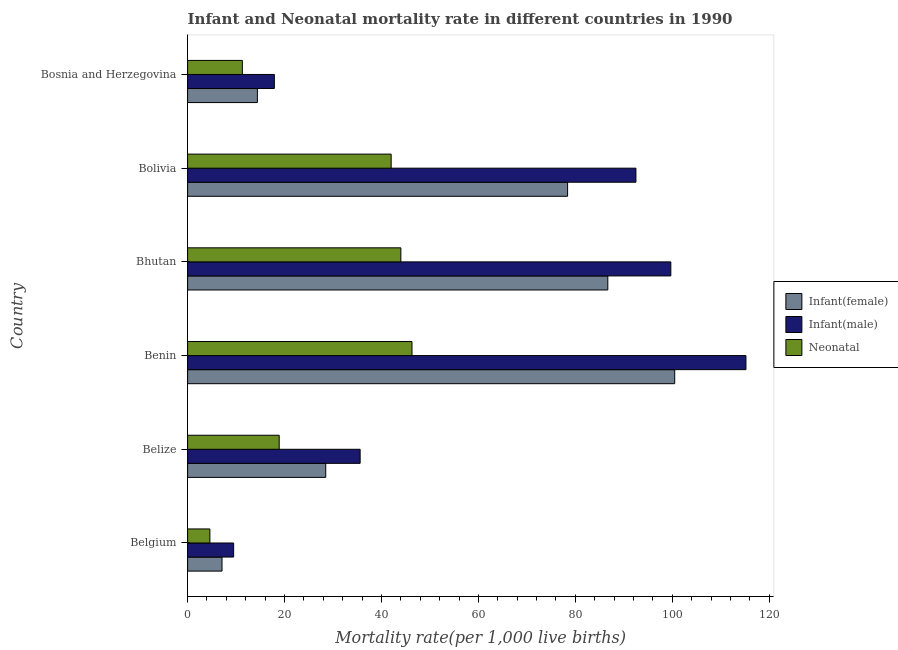How many different coloured bars are there?
Offer a terse response. 3. Are the number of bars per tick equal to the number of legend labels?
Offer a very short reply. Yes. How many bars are there on the 2nd tick from the bottom?
Keep it short and to the point. 3. What is the label of the 4th group of bars from the top?
Ensure brevity in your answer.  Benin. In how many cases, is the number of bars for a given country not equal to the number of legend labels?
Your answer should be very brief. 0. Across all countries, what is the maximum infant mortality rate(female)?
Offer a very short reply. 100.5. Across all countries, what is the minimum infant mortality rate(male)?
Your answer should be compact. 9.5. In which country was the neonatal mortality rate maximum?
Your answer should be very brief. Benin. In which country was the infant mortality rate(male) minimum?
Give a very brief answer. Belgium. What is the total infant mortality rate(female) in the graph?
Provide a succinct answer. 315.6. What is the difference between the infant mortality rate(female) in Belgium and that in Belize?
Your answer should be very brief. -21.4. What is the difference between the infant mortality rate(female) in Benin and the neonatal mortality rate in Bosnia and Herzegovina?
Make the answer very short. 89.2. What is the average infant mortality rate(male) per country?
Keep it short and to the point. 61.73. What is the difference between the neonatal mortality rate and infant mortality rate(female) in Benin?
Make the answer very short. -54.2. In how many countries, is the infant mortality rate(female) greater than 92 ?
Your answer should be compact. 1. What is the ratio of the neonatal mortality rate in Belgium to that in Belize?
Provide a short and direct response. 0.24. Is the infant mortality rate(female) in Belgium less than that in Bhutan?
Your answer should be compact. Yes. Is the difference between the infant mortality rate(male) in Belize and Bosnia and Herzegovina greater than the difference between the infant mortality rate(female) in Belize and Bosnia and Herzegovina?
Your response must be concise. Yes. What is the difference between the highest and the lowest infant mortality rate(female)?
Make the answer very short. 93.4. Is the sum of the infant mortality rate(female) in Bhutan and Bolivia greater than the maximum neonatal mortality rate across all countries?
Keep it short and to the point. Yes. What does the 3rd bar from the top in Belgium represents?
Make the answer very short. Infant(female). What does the 2nd bar from the bottom in Bolivia represents?
Your answer should be compact. Infant(male). Are all the bars in the graph horizontal?
Your answer should be very brief. Yes. How many countries are there in the graph?
Offer a terse response. 6. Does the graph contain grids?
Provide a succinct answer. No. How many legend labels are there?
Give a very brief answer. 3. What is the title of the graph?
Your response must be concise. Infant and Neonatal mortality rate in different countries in 1990. Does "Ages 15-20" appear as one of the legend labels in the graph?
Provide a short and direct response. No. What is the label or title of the X-axis?
Provide a succinct answer. Mortality rate(per 1,0 live births). What is the Mortality rate(per 1,000 live births) in Infant(female) in Belgium?
Keep it short and to the point. 7.1. What is the Mortality rate(per 1,000 live births) of Infant(male) in Belgium?
Provide a short and direct response. 9.5. What is the Mortality rate(per 1,000 live births) in Infant(male) in Belize?
Make the answer very short. 35.6. What is the Mortality rate(per 1,000 live births) in Infant(female) in Benin?
Your answer should be very brief. 100.5. What is the Mortality rate(per 1,000 live births) of Infant(male) in Benin?
Keep it short and to the point. 115.2. What is the Mortality rate(per 1,000 live births) in Neonatal  in Benin?
Make the answer very short. 46.3. What is the Mortality rate(per 1,000 live births) in Infant(female) in Bhutan?
Provide a succinct answer. 86.7. What is the Mortality rate(per 1,000 live births) of Infant(male) in Bhutan?
Keep it short and to the point. 99.7. What is the Mortality rate(per 1,000 live births) of Infant(female) in Bolivia?
Make the answer very short. 78.4. What is the Mortality rate(per 1,000 live births) of Infant(male) in Bolivia?
Keep it short and to the point. 92.5. What is the Mortality rate(per 1,000 live births) of Neonatal  in Bolivia?
Your answer should be compact. 42. What is the Mortality rate(per 1,000 live births) in Infant(female) in Bosnia and Herzegovina?
Provide a succinct answer. 14.4. What is the Mortality rate(per 1,000 live births) in Infant(male) in Bosnia and Herzegovina?
Give a very brief answer. 17.9. What is the Mortality rate(per 1,000 live births) in Neonatal  in Bosnia and Herzegovina?
Provide a succinct answer. 11.3. Across all countries, what is the maximum Mortality rate(per 1,000 live births) in Infant(female)?
Your response must be concise. 100.5. Across all countries, what is the maximum Mortality rate(per 1,000 live births) of Infant(male)?
Keep it short and to the point. 115.2. Across all countries, what is the maximum Mortality rate(per 1,000 live births) in Neonatal ?
Keep it short and to the point. 46.3. What is the total Mortality rate(per 1,000 live births) in Infant(female) in the graph?
Your response must be concise. 315.6. What is the total Mortality rate(per 1,000 live births) in Infant(male) in the graph?
Give a very brief answer. 370.4. What is the total Mortality rate(per 1,000 live births) of Neonatal  in the graph?
Your response must be concise. 167.1. What is the difference between the Mortality rate(per 1,000 live births) of Infant(female) in Belgium and that in Belize?
Make the answer very short. -21.4. What is the difference between the Mortality rate(per 1,000 live births) in Infant(male) in Belgium and that in Belize?
Make the answer very short. -26.1. What is the difference between the Mortality rate(per 1,000 live births) of Neonatal  in Belgium and that in Belize?
Your answer should be compact. -14.3. What is the difference between the Mortality rate(per 1,000 live births) of Infant(female) in Belgium and that in Benin?
Provide a succinct answer. -93.4. What is the difference between the Mortality rate(per 1,000 live births) in Infant(male) in Belgium and that in Benin?
Your answer should be compact. -105.7. What is the difference between the Mortality rate(per 1,000 live births) in Neonatal  in Belgium and that in Benin?
Ensure brevity in your answer.  -41.7. What is the difference between the Mortality rate(per 1,000 live births) in Infant(female) in Belgium and that in Bhutan?
Your answer should be very brief. -79.6. What is the difference between the Mortality rate(per 1,000 live births) in Infant(male) in Belgium and that in Bhutan?
Offer a very short reply. -90.2. What is the difference between the Mortality rate(per 1,000 live births) of Neonatal  in Belgium and that in Bhutan?
Give a very brief answer. -39.4. What is the difference between the Mortality rate(per 1,000 live births) of Infant(female) in Belgium and that in Bolivia?
Offer a very short reply. -71.3. What is the difference between the Mortality rate(per 1,000 live births) in Infant(male) in Belgium and that in Bolivia?
Your answer should be compact. -83. What is the difference between the Mortality rate(per 1,000 live births) in Neonatal  in Belgium and that in Bolivia?
Provide a succinct answer. -37.4. What is the difference between the Mortality rate(per 1,000 live births) in Infant(female) in Belgium and that in Bosnia and Herzegovina?
Provide a succinct answer. -7.3. What is the difference between the Mortality rate(per 1,000 live births) in Neonatal  in Belgium and that in Bosnia and Herzegovina?
Give a very brief answer. -6.7. What is the difference between the Mortality rate(per 1,000 live births) of Infant(female) in Belize and that in Benin?
Your answer should be compact. -72. What is the difference between the Mortality rate(per 1,000 live births) of Infant(male) in Belize and that in Benin?
Make the answer very short. -79.6. What is the difference between the Mortality rate(per 1,000 live births) in Neonatal  in Belize and that in Benin?
Your answer should be very brief. -27.4. What is the difference between the Mortality rate(per 1,000 live births) of Infant(female) in Belize and that in Bhutan?
Keep it short and to the point. -58.2. What is the difference between the Mortality rate(per 1,000 live births) of Infant(male) in Belize and that in Bhutan?
Offer a terse response. -64.1. What is the difference between the Mortality rate(per 1,000 live births) of Neonatal  in Belize and that in Bhutan?
Ensure brevity in your answer.  -25.1. What is the difference between the Mortality rate(per 1,000 live births) of Infant(female) in Belize and that in Bolivia?
Ensure brevity in your answer.  -49.9. What is the difference between the Mortality rate(per 1,000 live births) of Infant(male) in Belize and that in Bolivia?
Give a very brief answer. -56.9. What is the difference between the Mortality rate(per 1,000 live births) in Neonatal  in Belize and that in Bolivia?
Ensure brevity in your answer.  -23.1. What is the difference between the Mortality rate(per 1,000 live births) in Infant(female) in Belize and that in Bosnia and Herzegovina?
Your response must be concise. 14.1. What is the difference between the Mortality rate(per 1,000 live births) of Infant(male) in Belize and that in Bosnia and Herzegovina?
Ensure brevity in your answer.  17.7. What is the difference between the Mortality rate(per 1,000 live births) of Neonatal  in Belize and that in Bosnia and Herzegovina?
Give a very brief answer. 7.6. What is the difference between the Mortality rate(per 1,000 live births) in Infant(female) in Benin and that in Bhutan?
Give a very brief answer. 13.8. What is the difference between the Mortality rate(per 1,000 live births) in Neonatal  in Benin and that in Bhutan?
Make the answer very short. 2.3. What is the difference between the Mortality rate(per 1,000 live births) of Infant(female) in Benin and that in Bolivia?
Provide a succinct answer. 22.1. What is the difference between the Mortality rate(per 1,000 live births) in Infant(male) in Benin and that in Bolivia?
Your response must be concise. 22.7. What is the difference between the Mortality rate(per 1,000 live births) of Infant(female) in Benin and that in Bosnia and Herzegovina?
Offer a terse response. 86.1. What is the difference between the Mortality rate(per 1,000 live births) in Infant(male) in Benin and that in Bosnia and Herzegovina?
Your answer should be very brief. 97.3. What is the difference between the Mortality rate(per 1,000 live births) of Neonatal  in Benin and that in Bosnia and Herzegovina?
Offer a very short reply. 35. What is the difference between the Mortality rate(per 1,000 live births) of Neonatal  in Bhutan and that in Bolivia?
Your answer should be very brief. 2. What is the difference between the Mortality rate(per 1,000 live births) in Infant(female) in Bhutan and that in Bosnia and Herzegovina?
Your answer should be very brief. 72.3. What is the difference between the Mortality rate(per 1,000 live births) of Infant(male) in Bhutan and that in Bosnia and Herzegovina?
Offer a terse response. 81.8. What is the difference between the Mortality rate(per 1,000 live births) in Neonatal  in Bhutan and that in Bosnia and Herzegovina?
Offer a terse response. 32.7. What is the difference between the Mortality rate(per 1,000 live births) in Infant(female) in Bolivia and that in Bosnia and Herzegovina?
Offer a terse response. 64. What is the difference between the Mortality rate(per 1,000 live births) of Infant(male) in Bolivia and that in Bosnia and Herzegovina?
Provide a succinct answer. 74.6. What is the difference between the Mortality rate(per 1,000 live births) in Neonatal  in Bolivia and that in Bosnia and Herzegovina?
Your response must be concise. 30.7. What is the difference between the Mortality rate(per 1,000 live births) in Infant(female) in Belgium and the Mortality rate(per 1,000 live births) in Infant(male) in Belize?
Make the answer very short. -28.5. What is the difference between the Mortality rate(per 1,000 live births) in Infant(male) in Belgium and the Mortality rate(per 1,000 live births) in Neonatal  in Belize?
Provide a succinct answer. -9.4. What is the difference between the Mortality rate(per 1,000 live births) in Infant(female) in Belgium and the Mortality rate(per 1,000 live births) in Infant(male) in Benin?
Provide a short and direct response. -108.1. What is the difference between the Mortality rate(per 1,000 live births) of Infant(female) in Belgium and the Mortality rate(per 1,000 live births) of Neonatal  in Benin?
Your answer should be very brief. -39.2. What is the difference between the Mortality rate(per 1,000 live births) in Infant(male) in Belgium and the Mortality rate(per 1,000 live births) in Neonatal  in Benin?
Make the answer very short. -36.8. What is the difference between the Mortality rate(per 1,000 live births) in Infant(female) in Belgium and the Mortality rate(per 1,000 live births) in Infant(male) in Bhutan?
Offer a terse response. -92.6. What is the difference between the Mortality rate(per 1,000 live births) in Infant(female) in Belgium and the Mortality rate(per 1,000 live births) in Neonatal  in Bhutan?
Your response must be concise. -36.9. What is the difference between the Mortality rate(per 1,000 live births) of Infant(male) in Belgium and the Mortality rate(per 1,000 live births) of Neonatal  in Bhutan?
Keep it short and to the point. -34.5. What is the difference between the Mortality rate(per 1,000 live births) of Infant(female) in Belgium and the Mortality rate(per 1,000 live births) of Infant(male) in Bolivia?
Provide a short and direct response. -85.4. What is the difference between the Mortality rate(per 1,000 live births) in Infant(female) in Belgium and the Mortality rate(per 1,000 live births) in Neonatal  in Bolivia?
Provide a succinct answer. -34.9. What is the difference between the Mortality rate(per 1,000 live births) in Infant(male) in Belgium and the Mortality rate(per 1,000 live births) in Neonatal  in Bolivia?
Keep it short and to the point. -32.5. What is the difference between the Mortality rate(per 1,000 live births) of Infant(female) in Belgium and the Mortality rate(per 1,000 live births) of Infant(male) in Bosnia and Herzegovina?
Ensure brevity in your answer.  -10.8. What is the difference between the Mortality rate(per 1,000 live births) of Infant(male) in Belgium and the Mortality rate(per 1,000 live births) of Neonatal  in Bosnia and Herzegovina?
Your response must be concise. -1.8. What is the difference between the Mortality rate(per 1,000 live births) in Infant(female) in Belize and the Mortality rate(per 1,000 live births) in Infant(male) in Benin?
Make the answer very short. -86.7. What is the difference between the Mortality rate(per 1,000 live births) in Infant(female) in Belize and the Mortality rate(per 1,000 live births) in Neonatal  in Benin?
Your response must be concise. -17.8. What is the difference between the Mortality rate(per 1,000 live births) of Infant(female) in Belize and the Mortality rate(per 1,000 live births) of Infant(male) in Bhutan?
Provide a succinct answer. -71.2. What is the difference between the Mortality rate(per 1,000 live births) of Infant(female) in Belize and the Mortality rate(per 1,000 live births) of Neonatal  in Bhutan?
Offer a terse response. -15.5. What is the difference between the Mortality rate(per 1,000 live births) of Infant(female) in Belize and the Mortality rate(per 1,000 live births) of Infant(male) in Bolivia?
Ensure brevity in your answer.  -64. What is the difference between the Mortality rate(per 1,000 live births) of Infant(male) in Belize and the Mortality rate(per 1,000 live births) of Neonatal  in Bolivia?
Ensure brevity in your answer.  -6.4. What is the difference between the Mortality rate(per 1,000 live births) in Infant(female) in Belize and the Mortality rate(per 1,000 live births) in Infant(male) in Bosnia and Herzegovina?
Offer a very short reply. 10.6. What is the difference between the Mortality rate(per 1,000 live births) of Infant(female) in Belize and the Mortality rate(per 1,000 live births) of Neonatal  in Bosnia and Herzegovina?
Offer a very short reply. 17.2. What is the difference between the Mortality rate(per 1,000 live births) of Infant(male) in Belize and the Mortality rate(per 1,000 live births) of Neonatal  in Bosnia and Herzegovina?
Your response must be concise. 24.3. What is the difference between the Mortality rate(per 1,000 live births) in Infant(female) in Benin and the Mortality rate(per 1,000 live births) in Infant(male) in Bhutan?
Provide a short and direct response. 0.8. What is the difference between the Mortality rate(per 1,000 live births) in Infant(female) in Benin and the Mortality rate(per 1,000 live births) in Neonatal  in Bhutan?
Provide a succinct answer. 56.5. What is the difference between the Mortality rate(per 1,000 live births) of Infant(male) in Benin and the Mortality rate(per 1,000 live births) of Neonatal  in Bhutan?
Provide a short and direct response. 71.2. What is the difference between the Mortality rate(per 1,000 live births) of Infant(female) in Benin and the Mortality rate(per 1,000 live births) of Neonatal  in Bolivia?
Offer a terse response. 58.5. What is the difference between the Mortality rate(per 1,000 live births) in Infant(male) in Benin and the Mortality rate(per 1,000 live births) in Neonatal  in Bolivia?
Offer a very short reply. 73.2. What is the difference between the Mortality rate(per 1,000 live births) of Infant(female) in Benin and the Mortality rate(per 1,000 live births) of Infant(male) in Bosnia and Herzegovina?
Make the answer very short. 82.6. What is the difference between the Mortality rate(per 1,000 live births) in Infant(female) in Benin and the Mortality rate(per 1,000 live births) in Neonatal  in Bosnia and Herzegovina?
Your response must be concise. 89.2. What is the difference between the Mortality rate(per 1,000 live births) in Infant(male) in Benin and the Mortality rate(per 1,000 live births) in Neonatal  in Bosnia and Herzegovina?
Your answer should be very brief. 103.9. What is the difference between the Mortality rate(per 1,000 live births) in Infant(female) in Bhutan and the Mortality rate(per 1,000 live births) in Neonatal  in Bolivia?
Your answer should be compact. 44.7. What is the difference between the Mortality rate(per 1,000 live births) of Infant(male) in Bhutan and the Mortality rate(per 1,000 live births) of Neonatal  in Bolivia?
Provide a succinct answer. 57.7. What is the difference between the Mortality rate(per 1,000 live births) of Infant(female) in Bhutan and the Mortality rate(per 1,000 live births) of Infant(male) in Bosnia and Herzegovina?
Keep it short and to the point. 68.8. What is the difference between the Mortality rate(per 1,000 live births) of Infant(female) in Bhutan and the Mortality rate(per 1,000 live births) of Neonatal  in Bosnia and Herzegovina?
Ensure brevity in your answer.  75.4. What is the difference between the Mortality rate(per 1,000 live births) of Infant(male) in Bhutan and the Mortality rate(per 1,000 live births) of Neonatal  in Bosnia and Herzegovina?
Keep it short and to the point. 88.4. What is the difference between the Mortality rate(per 1,000 live births) of Infant(female) in Bolivia and the Mortality rate(per 1,000 live births) of Infant(male) in Bosnia and Herzegovina?
Provide a succinct answer. 60.5. What is the difference between the Mortality rate(per 1,000 live births) in Infant(female) in Bolivia and the Mortality rate(per 1,000 live births) in Neonatal  in Bosnia and Herzegovina?
Your answer should be compact. 67.1. What is the difference between the Mortality rate(per 1,000 live births) in Infant(male) in Bolivia and the Mortality rate(per 1,000 live births) in Neonatal  in Bosnia and Herzegovina?
Your response must be concise. 81.2. What is the average Mortality rate(per 1,000 live births) of Infant(female) per country?
Provide a succinct answer. 52.6. What is the average Mortality rate(per 1,000 live births) of Infant(male) per country?
Offer a very short reply. 61.73. What is the average Mortality rate(per 1,000 live births) in Neonatal  per country?
Make the answer very short. 27.85. What is the difference between the Mortality rate(per 1,000 live births) in Infant(female) and Mortality rate(per 1,000 live births) in Infant(male) in Belgium?
Ensure brevity in your answer.  -2.4. What is the difference between the Mortality rate(per 1,000 live births) in Infant(male) and Mortality rate(per 1,000 live births) in Neonatal  in Belgium?
Ensure brevity in your answer.  4.9. What is the difference between the Mortality rate(per 1,000 live births) in Infant(female) and Mortality rate(per 1,000 live births) in Neonatal  in Belize?
Your response must be concise. 9.6. What is the difference between the Mortality rate(per 1,000 live births) in Infant(male) and Mortality rate(per 1,000 live births) in Neonatal  in Belize?
Keep it short and to the point. 16.7. What is the difference between the Mortality rate(per 1,000 live births) in Infant(female) and Mortality rate(per 1,000 live births) in Infant(male) in Benin?
Your answer should be compact. -14.7. What is the difference between the Mortality rate(per 1,000 live births) in Infant(female) and Mortality rate(per 1,000 live births) in Neonatal  in Benin?
Provide a succinct answer. 54.2. What is the difference between the Mortality rate(per 1,000 live births) in Infant(male) and Mortality rate(per 1,000 live births) in Neonatal  in Benin?
Provide a succinct answer. 68.9. What is the difference between the Mortality rate(per 1,000 live births) in Infant(female) and Mortality rate(per 1,000 live births) in Neonatal  in Bhutan?
Offer a terse response. 42.7. What is the difference between the Mortality rate(per 1,000 live births) of Infant(male) and Mortality rate(per 1,000 live births) of Neonatal  in Bhutan?
Offer a terse response. 55.7. What is the difference between the Mortality rate(per 1,000 live births) in Infant(female) and Mortality rate(per 1,000 live births) in Infant(male) in Bolivia?
Keep it short and to the point. -14.1. What is the difference between the Mortality rate(per 1,000 live births) in Infant(female) and Mortality rate(per 1,000 live births) in Neonatal  in Bolivia?
Your answer should be very brief. 36.4. What is the difference between the Mortality rate(per 1,000 live births) of Infant(male) and Mortality rate(per 1,000 live births) of Neonatal  in Bolivia?
Keep it short and to the point. 50.5. What is the difference between the Mortality rate(per 1,000 live births) in Infant(female) and Mortality rate(per 1,000 live births) in Neonatal  in Bosnia and Herzegovina?
Your answer should be compact. 3.1. What is the difference between the Mortality rate(per 1,000 live births) of Infant(male) and Mortality rate(per 1,000 live births) of Neonatal  in Bosnia and Herzegovina?
Keep it short and to the point. 6.6. What is the ratio of the Mortality rate(per 1,000 live births) of Infant(female) in Belgium to that in Belize?
Your answer should be compact. 0.25. What is the ratio of the Mortality rate(per 1,000 live births) of Infant(male) in Belgium to that in Belize?
Provide a succinct answer. 0.27. What is the ratio of the Mortality rate(per 1,000 live births) of Neonatal  in Belgium to that in Belize?
Provide a short and direct response. 0.24. What is the ratio of the Mortality rate(per 1,000 live births) of Infant(female) in Belgium to that in Benin?
Your answer should be very brief. 0.07. What is the ratio of the Mortality rate(per 1,000 live births) in Infant(male) in Belgium to that in Benin?
Provide a short and direct response. 0.08. What is the ratio of the Mortality rate(per 1,000 live births) in Neonatal  in Belgium to that in Benin?
Keep it short and to the point. 0.1. What is the ratio of the Mortality rate(per 1,000 live births) of Infant(female) in Belgium to that in Bhutan?
Ensure brevity in your answer.  0.08. What is the ratio of the Mortality rate(per 1,000 live births) in Infant(male) in Belgium to that in Bhutan?
Offer a very short reply. 0.1. What is the ratio of the Mortality rate(per 1,000 live births) in Neonatal  in Belgium to that in Bhutan?
Make the answer very short. 0.1. What is the ratio of the Mortality rate(per 1,000 live births) of Infant(female) in Belgium to that in Bolivia?
Offer a very short reply. 0.09. What is the ratio of the Mortality rate(per 1,000 live births) in Infant(male) in Belgium to that in Bolivia?
Offer a very short reply. 0.1. What is the ratio of the Mortality rate(per 1,000 live births) in Neonatal  in Belgium to that in Bolivia?
Make the answer very short. 0.11. What is the ratio of the Mortality rate(per 1,000 live births) of Infant(female) in Belgium to that in Bosnia and Herzegovina?
Give a very brief answer. 0.49. What is the ratio of the Mortality rate(per 1,000 live births) in Infant(male) in Belgium to that in Bosnia and Herzegovina?
Give a very brief answer. 0.53. What is the ratio of the Mortality rate(per 1,000 live births) in Neonatal  in Belgium to that in Bosnia and Herzegovina?
Provide a succinct answer. 0.41. What is the ratio of the Mortality rate(per 1,000 live births) of Infant(female) in Belize to that in Benin?
Provide a succinct answer. 0.28. What is the ratio of the Mortality rate(per 1,000 live births) of Infant(male) in Belize to that in Benin?
Offer a terse response. 0.31. What is the ratio of the Mortality rate(per 1,000 live births) of Neonatal  in Belize to that in Benin?
Your response must be concise. 0.41. What is the ratio of the Mortality rate(per 1,000 live births) in Infant(female) in Belize to that in Bhutan?
Give a very brief answer. 0.33. What is the ratio of the Mortality rate(per 1,000 live births) in Infant(male) in Belize to that in Bhutan?
Your answer should be very brief. 0.36. What is the ratio of the Mortality rate(per 1,000 live births) of Neonatal  in Belize to that in Bhutan?
Give a very brief answer. 0.43. What is the ratio of the Mortality rate(per 1,000 live births) in Infant(female) in Belize to that in Bolivia?
Provide a short and direct response. 0.36. What is the ratio of the Mortality rate(per 1,000 live births) of Infant(male) in Belize to that in Bolivia?
Ensure brevity in your answer.  0.38. What is the ratio of the Mortality rate(per 1,000 live births) in Neonatal  in Belize to that in Bolivia?
Offer a very short reply. 0.45. What is the ratio of the Mortality rate(per 1,000 live births) in Infant(female) in Belize to that in Bosnia and Herzegovina?
Your response must be concise. 1.98. What is the ratio of the Mortality rate(per 1,000 live births) of Infant(male) in Belize to that in Bosnia and Herzegovina?
Provide a short and direct response. 1.99. What is the ratio of the Mortality rate(per 1,000 live births) in Neonatal  in Belize to that in Bosnia and Herzegovina?
Provide a short and direct response. 1.67. What is the ratio of the Mortality rate(per 1,000 live births) of Infant(female) in Benin to that in Bhutan?
Your answer should be very brief. 1.16. What is the ratio of the Mortality rate(per 1,000 live births) of Infant(male) in Benin to that in Bhutan?
Your response must be concise. 1.16. What is the ratio of the Mortality rate(per 1,000 live births) of Neonatal  in Benin to that in Bhutan?
Offer a very short reply. 1.05. What is the ratio of the Mortality rate(per 1,000 live births) in Infant(female) in Benin to that in Bolivia?
Provide a short and direct response. 1.28. What is the ratio of the Mortality rate(per 1,000 live births) of Infant(male) in Benin to that in Bolivia?
Give a very brief answer. 1.25. What is the ratio of the Mortality rate(per 1,000 live births) of Neonatal  in Benin to that in Bolivia?
Your answer should be very brief. 1.1. What is the ratio of the Mortality rate(per 1,000 live births) of Infant(female) in Benin to that in Bosnia and Herzegovina?
Provide a short and direct response. 6.98. What is the ratio of the Mortality rate(per 1,000 live births) in Infant(male) in Benin to that in Bosnia and Herzegovina?
Provide a short and direct response. 6.44. What is the ratio of the Mortality rate(per 1,000 live births) of Neonatal  in Benin to that in Bosnia and Herzegovina?
Your response must be concise. 4.1. What is the ratio of the Mortality rate(per 1,000 live births) of Infant(female) in Bhutan to that in Bolivia?
Offer a terse response. 1.11. What is the ratio of the Mortality rate(per 1,000 live births) in Infant(male) in Bhutan to that in Bolivia?
Your answer should be compact. 1.08. What is the ratio of the Mortality rate(per 1,000 live births) of Neonatal  in Bhutan to that in Bolivia?
Your answer should be very brief. 1.05. What is the ratio of the Mortality rate(per 1,000 live births) of Infant(female) in Bhutan to that in Bosnia and Herzegovina?
Ensure brevity in your answer.  6.02. What is the ratio of the Mortality rate(per 1,000 live births) of Infant(male) in Bhutan to that in Bosnia and Herzegovina?
Your answer should be compact. 5.57. What is the ratio of the Mortality rate(per 1,000 live births) of Neonatal  in Bhutan to that in Bosnia and Herzegovina?
Offer a terse response. 3.89. What is the ratio of the Mortality rate(per 1,000 live births) in Infant(female) in Bolivia to that in Bosnia and Herzegovina?
Give a very brief answer. 5.44. What is the ratio of the Mortality rate(per 1,000 live births) of Infant(male) in Bolivia to that in Bosnia and Herzegovina?
Provide a succinct answer. 5.17. What is the ratio of the Mortality rate(per 1,000 live births) in Neonatal  in Bolivia to that in Bosnia and Herzegovina?
Offer a very short reply. 3.72. What is the difference between the highest and the lowest Mortality rate(per 1,000 live births) of Infant(female)?
Your answer should be very brief. 93.4. What is the difference between the highest and the lowest Mortality rate(per 1,000 live births) of Infant(male)?
Offer a terse response. 105.7. What is the difference between the highest and the lowest Mortality rate(per 1,000 live births) of Neonatal ?
Your answer should be compact. 41.7. 